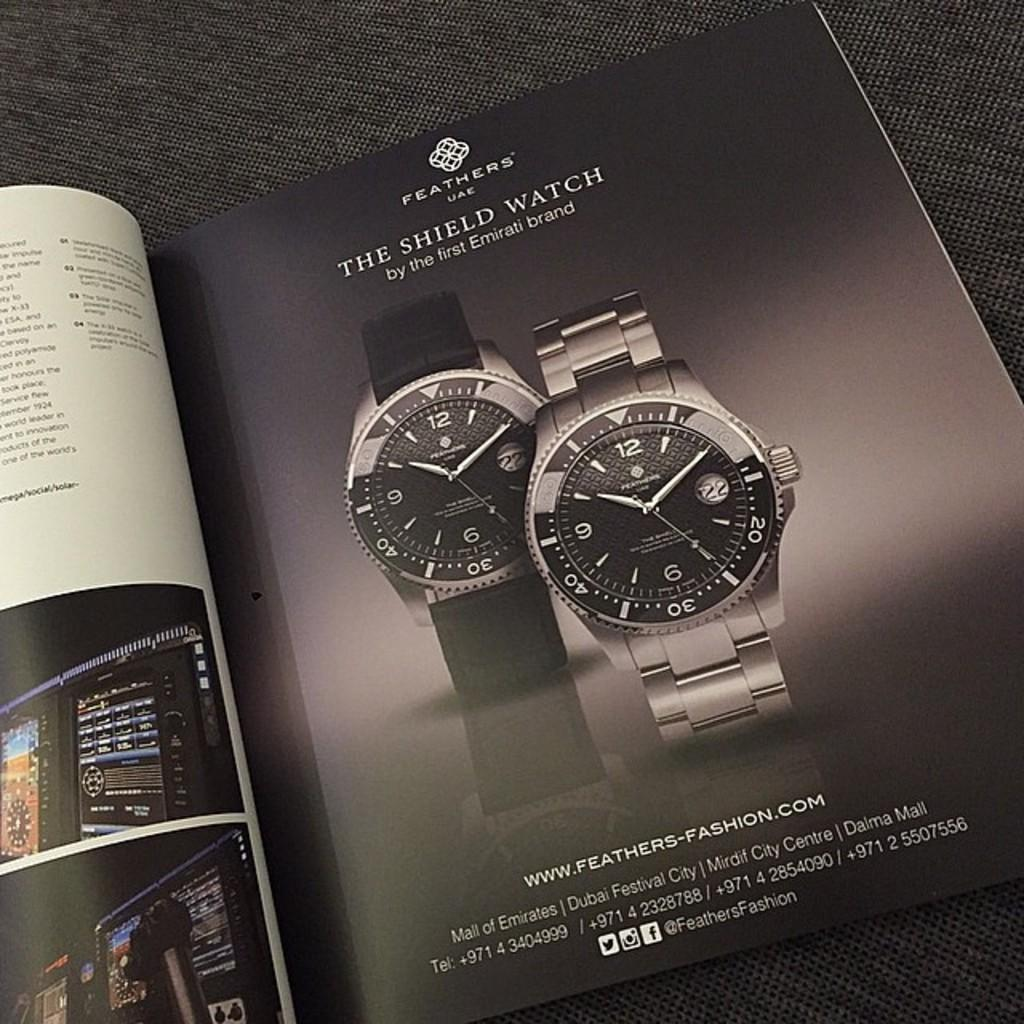<image>
Present a compact description of the photo's key features. An ad in the magazine is for Feathers shield watches. 